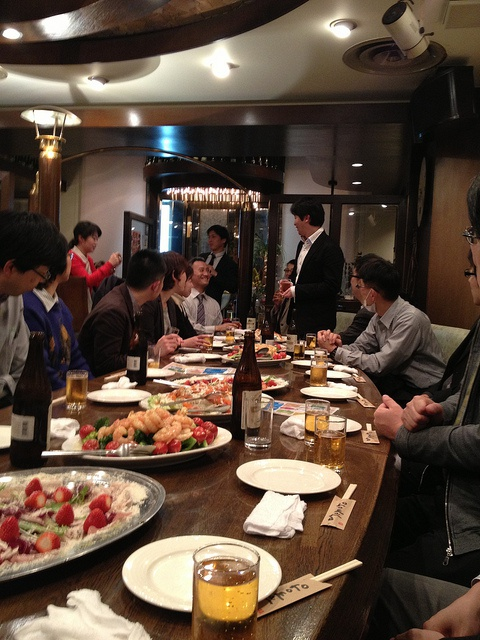Describe the objects in this image and their specific colors. I can see dining table in black, maroon, and beige tones, people in black, maroon, brown, and gray tones, people in black, gray, and maroon tones, people in black, gray, and maroon tones, and cup in black, orange, maroon, and brown tones in this image. 